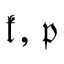Convert formula to latex. <formula><loc_0><loc_0><loc_500><loc_500>{ \mathfrak { k } } , { \mathfrak { p } }</formula> 